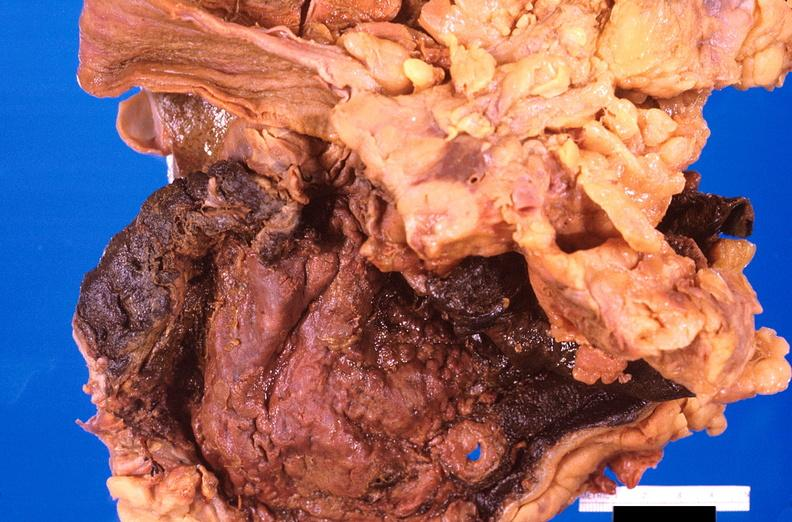what is present?
Answer the question using a single word or phrase. Gastrointestinal 